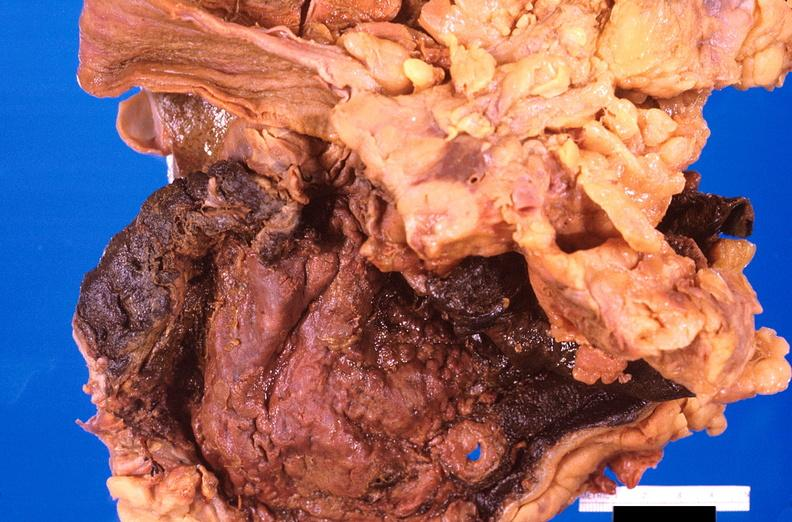what is present?
Answer the question using a single word or phrase. Gastrointestinal 